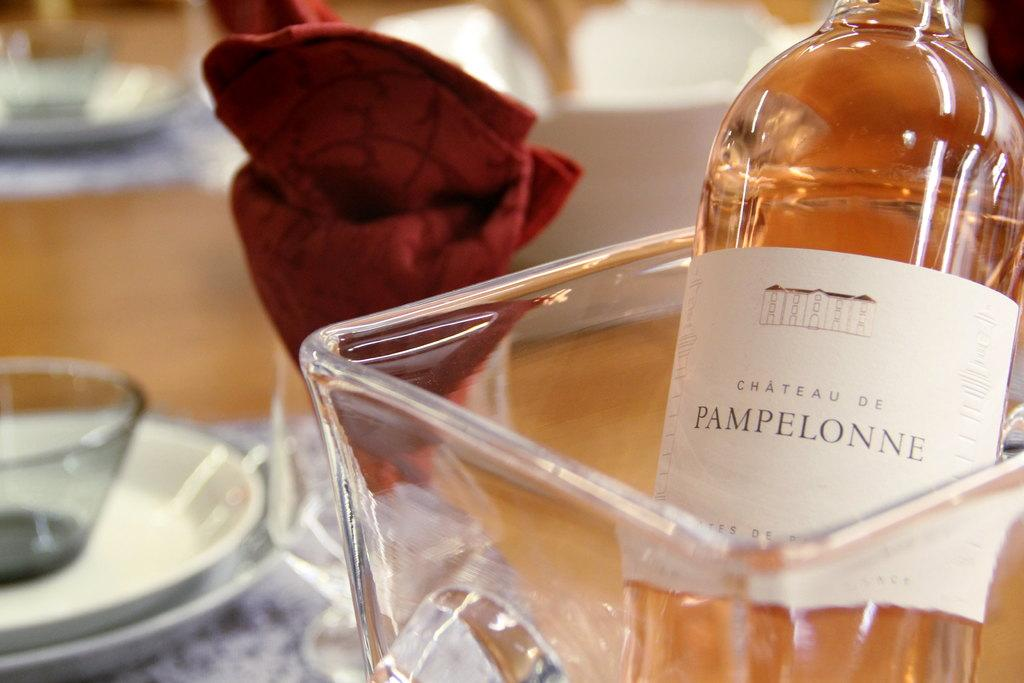<image>
Summarize the visual content of the image. a pampelonne bottle that has liquid in it 